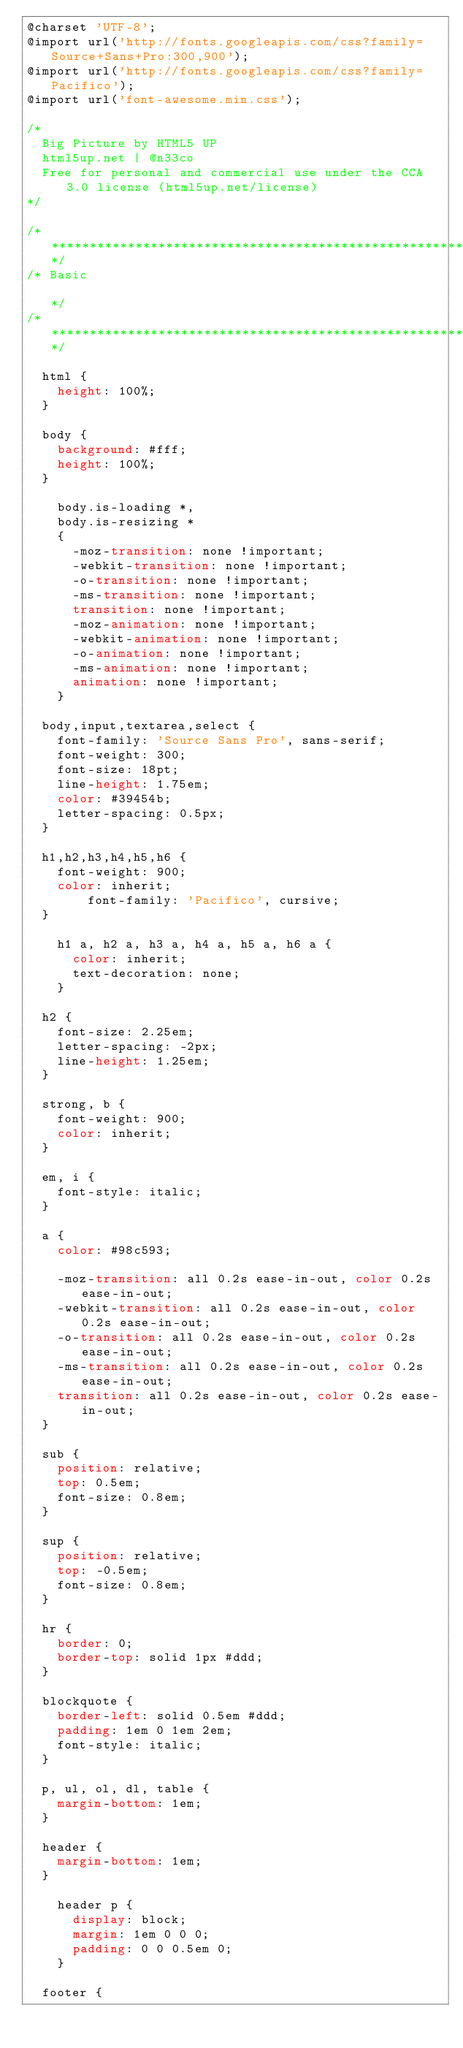Convert code to text. <code><loc_0><loc_0><loc_500><loc_500><_CSS_>@charset 'UTF-8';
@import url('http://fonts.googleapis.com/css?family=Source+Sans+Pro:300,900');
@import url('http://fonts.googleapis.com/css?family=Pacifico');
@import url('font-awesome.min.css');

/*
	Big Picture by HTML5 UP
	html5up.net | @n33co
	Free for personal and commercial use under the CCA 3.0 license (html5up.net/license)
*/

/*********************************************************************************/
/* Basic                                                                         */
/*********************************************************************************/

	html {
		height: 100%;
	}

	body {
		background: #fff;
		height: 100%;
	}

		body.is-loading *,
		body.is-resizing *
		{
			-moz-transition: none !important;
			-webkit-transition: none !important;
			-o-transition: none !important;
			-ms-transition: none !important;
			transition: none !important;
			-moz-animation: none !important;
			-webkit-animation: none !important;
			-o-animation: none !important;
			-ms-animation: none !important;
			animation: none !important;
		}

	body,input,textarea,select {
		font-family: 'Source Sans Pro', sans-serif;
		font-weight: 300;
		font-size: 18pt;
		line-height: 1.75em;
		color: #39454b;
		letter-spacing: 0.5px;
	}

	h1,h2,h3,h4,h5,h6 {
		font-weight: 900;
		color: inherit;
        font-family: 'Pacifico', cursive;
	}

		h1 a, h2 a, h3 a, h4 a, h5 a, h6 a {
			color: inherit;
			text-decoration: none;
		}

	h2 {
		font-size: 2.25em;
		letter-spacing: -2px;
		line-height: 1.25em;
	}

	strong, b {
		font-weight: 900;
		color: inherit;
	}

	em, i {
		font-style: italic;
	}

	a {
		color: #98c593;

		-moz-transition: all 0.2s ease-in-out, color 0.2s ease-in-out;
		-webkit-transition: all 0.2s ease-in-out, color 0.2s ease-in-out;
		-o-transition: all 0.2s ease-in-out, color 0.2s ease-in-out;
		-ms-transition: all 0.2s ease-in-out, color 0.2s ease-in-out;
		transition: all 0.2s ease-in-out, color 0.2s ease-in-out;
	}

	sub {
		position: relative;
		top: 0.5em;
		font-size: 0.8em;
	}

	sup {
		position: relative;
		top: -0.5em;
		font-size: 0.8em;
	}

	hr {
		border: 0;
		border-top: solid 1px #ddd;
	}

	blockquote {
		border-left: solid 0.5em #ddd;
		padding: 1em 0 1em 2em;
		font-style: italic;
	}

	p, ul, ol, dl, table {
		margin-bottom: 1em;
	}

	header {
		margin-bottom: 1em;
	}

		header p {
			display: block;
			margin: 1em 0 0 0;
			padding: 0 0 0.5em 0;
		}

	footer {</code> 